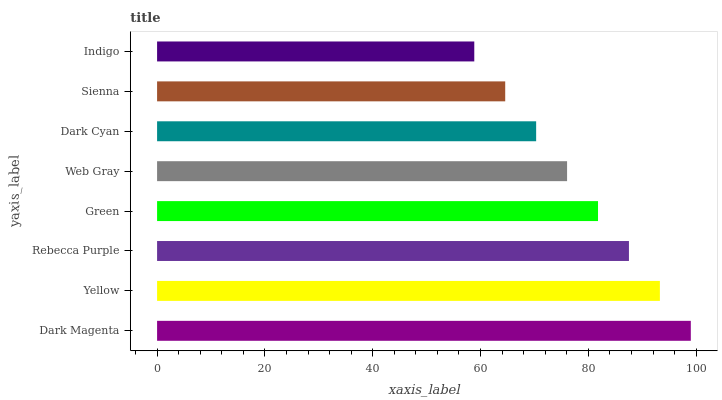Is Indigo the minimum?
Answer yes or no. Yes. Is Dark Magenta the maximum?
Answer yes or no. Yes. Is Yellow the minimum?
Answer yes or no. No. Is Yellow the maximum?
Answer yes or no. No. Is Dark Magenta greater than Yellow?
Answer yes or no. Yes. Is Yellow less than Dark Magenta?
Answer yes or no. Yes. Is Yellow greater than Dark Magenta?
Answer yes or no. No. Is Dark Magenta less than Yellow?
Answer yes or no. No. Is Green the high median?
Answer yes or no. Yes. Is Web Gray the low median?
Answer yes or no. Yes. Is Rebecca Purple the high median?
Answer yes or no. No. Is Sienna the low median?
Answer yes or no. No. 